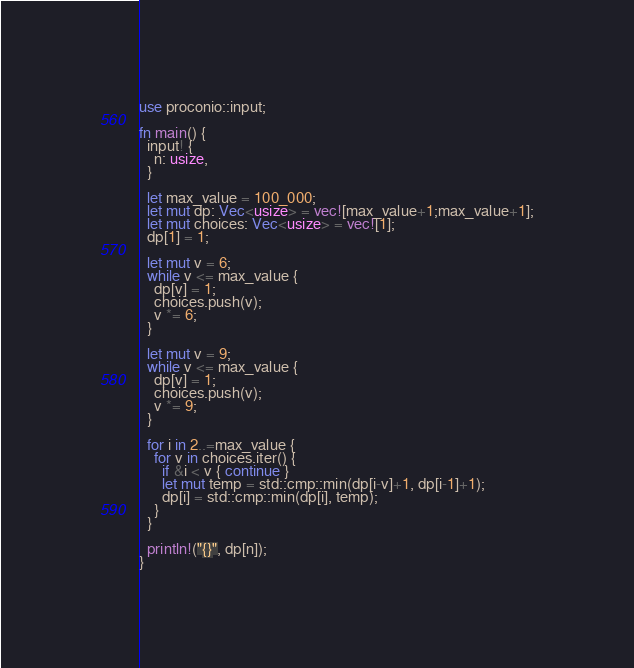<code> <loc_0><loc_0><loc_500><loc_500><_Rust_>use proconio::input;

fn main() {
  input! {
    n: usize,
  }
  
  let max_value = 100_000;
  let mut dp: Vec<usize> = vec![max_value+1;max_value+1];
  let mut choices: Vec<usize> = vec![1];
  dp[1] = 1;
  
  let mut v = 6;
  while v <= max_value {
    dp[v] = 1;
    choices.push(v);
    v *= 6;
  }

  let mut v = 9;
  while v <= max_value {
    dp[v] = 1;
    choices.push(v);
    v *= 9;
  }
  
  for i in 2..=max_value {
    for v in choices.iter() {
      if &i < v { continue }
      let mut temp = std::cmp::min(dp[i-v]+1, dp[i-1]+1);
      dp[i] = std::cmp::min(dp[i], temp);
    }
  }
  
  println!("{}", dp[n]);
}</code> 